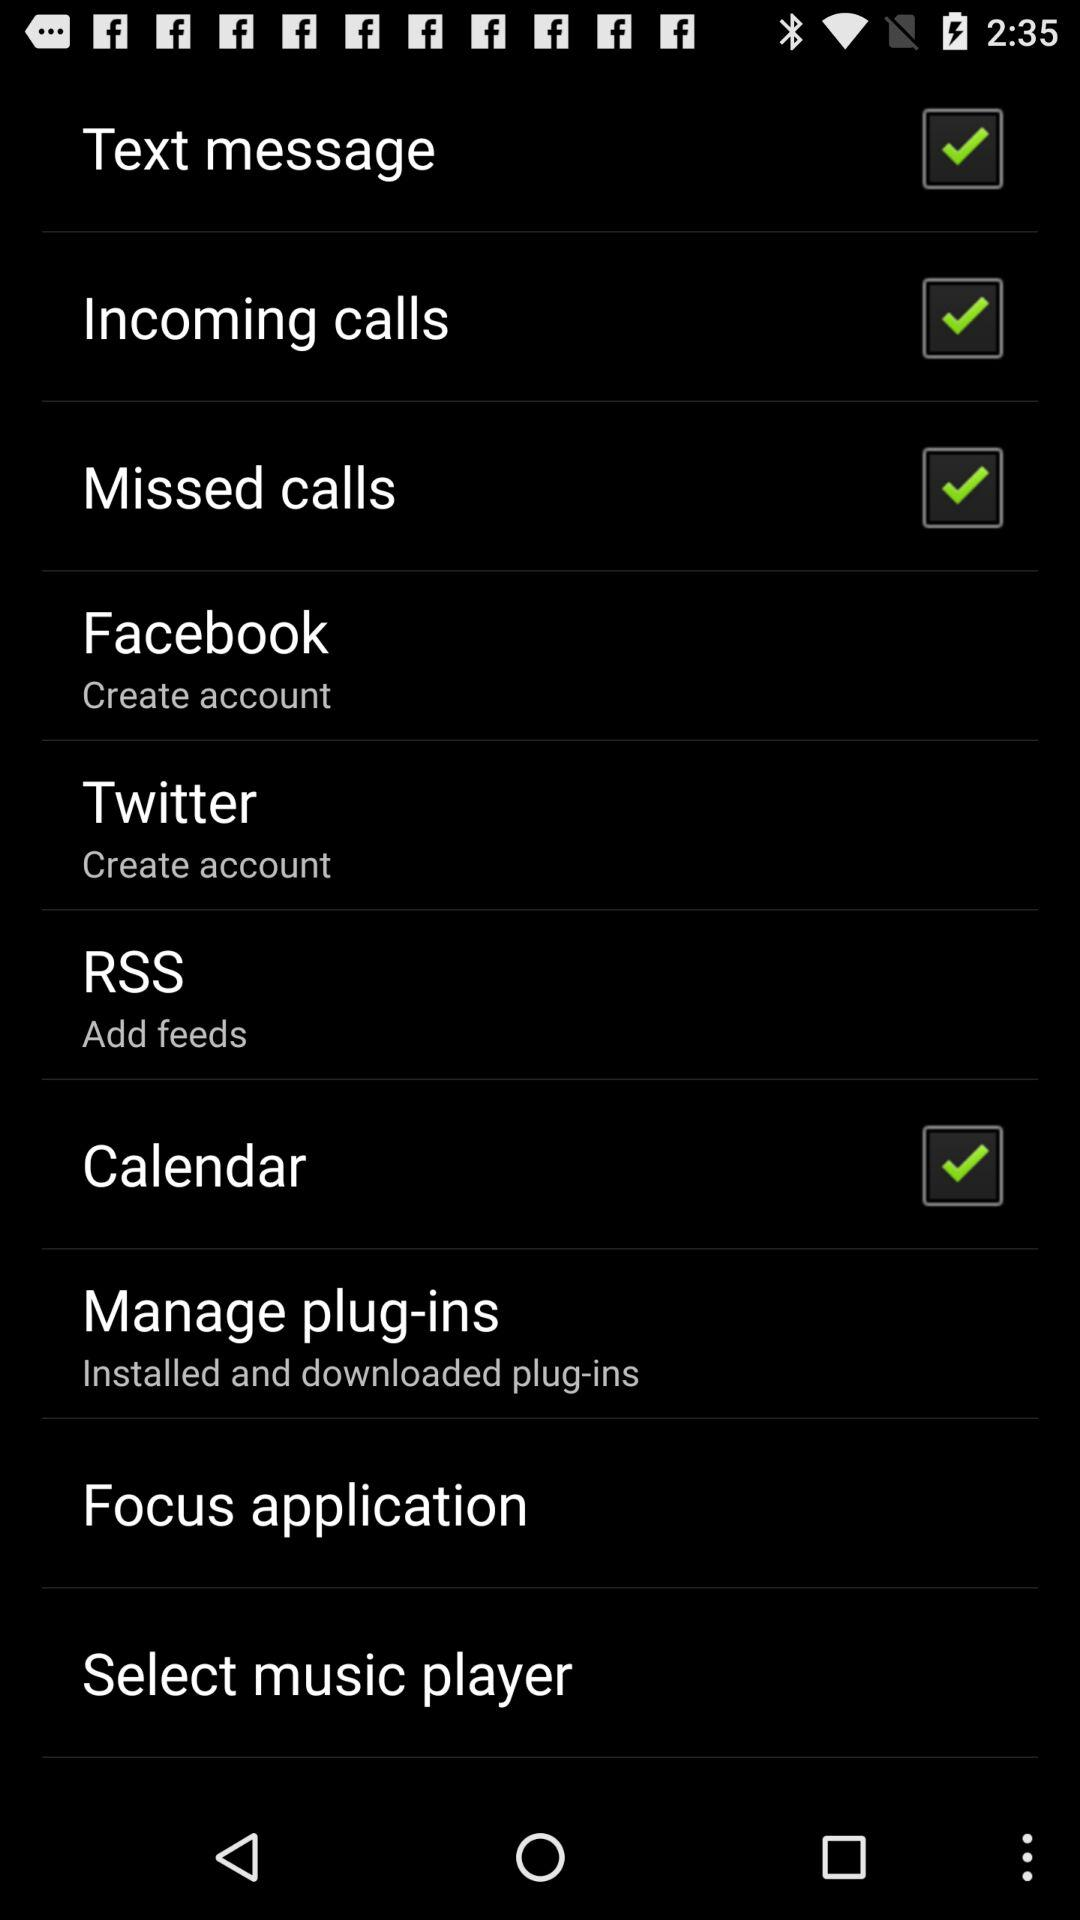What is the status of "Calendar"? The status is "on". 